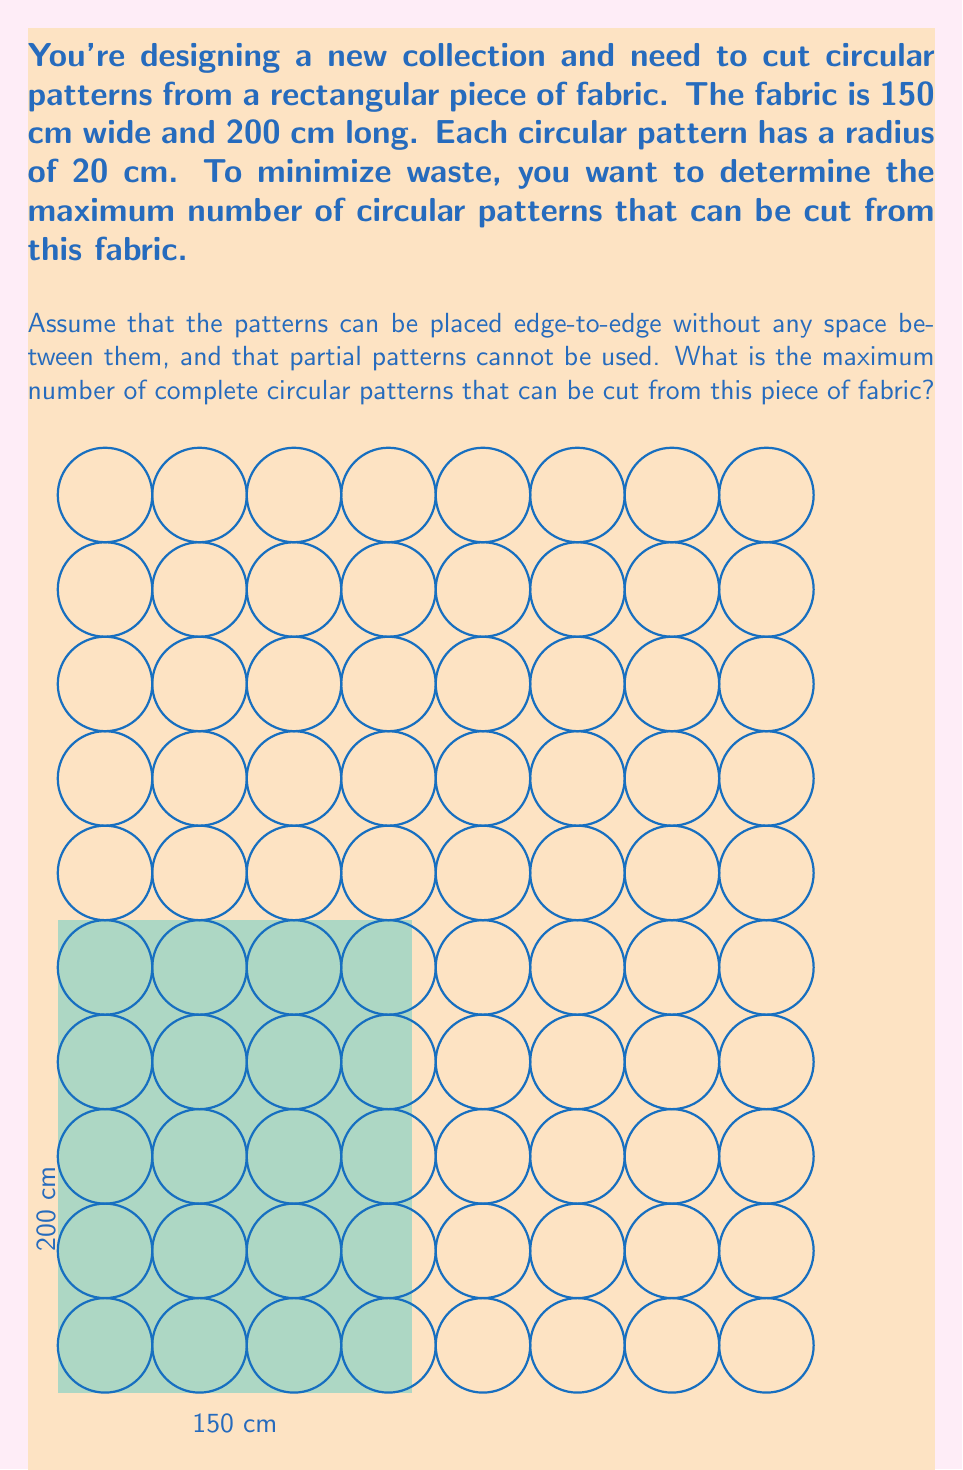Can you answer this question? Let's approach this step-by-step:

1) First, we need to calculate how many circles can fit along the width and length of the fabric:

   - Width: $150 \text{ cm} \div (2 \times 20 \text{ cm}) = 3.75$
   - Length: $200 \text{ cm} \div (2 \times 20 \text{ cm}) = 5$

2) We round down to the nearest whole number, as we can't use partial circles:
   - Width: 3 circles
   - Length: 5 circles

3) Now, we can calculate the total number of circles:

   $$ \text{Total circles} = 3 \times 5 = 15 $$

4) However, we can optimize further. Notice that we have some extra space:
   - Extra width: $150 \text{ cm} - (3 \times 40 \text{ cm}) = 30 \text{ cm}$
   - Extra length: $200 \text{ cm} - (5 \times 40 \text{ cm}) = 0 \text{ cm}$

5) We can fit one more column of circles in this 30 cm space:

   $$ \text{New total} = 4 \times 5 = 20 $$

6) To verify, let's check the total width used:
   $$ 4 \times 40 \text{ cm} = 160 \text{ cm} $$
   This exceeds our fabric width, so we need to adjust.

7) We can fit the circles in a staggered pattern to maximize space usage:
   - In odd rows: 4 circles
   - In even rows: 3 circles

8) Calculate the new total:
   $$ \text{Final total} = (3 \times 4) + (2 \times 3) = 18 $$

This arrangement fits within our fabric dimensions and maximizes the number of circles.
Answer: 18 circular patterns 